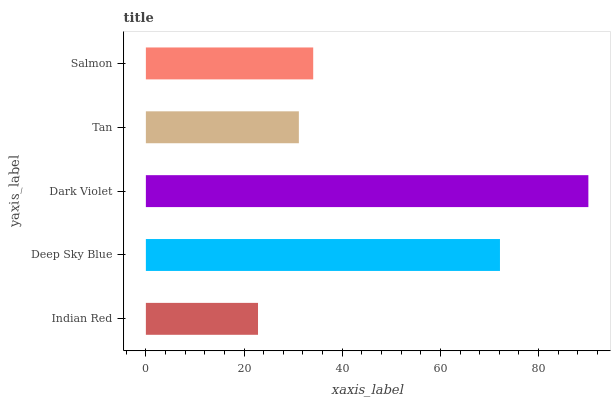Is Indian Red the minimum?
Answer yes or no. Yes. Is Dark Violet the maximum?
Answer yes or no. Yes. Is Deep Sky Blue the minimum?
Answer yes or no. No. Is Deep Sky Blue the maximum?
Answer yes or no. No. Is Deep Sky Blue greater than Indian Red?
Answer yes or no. Yes. Is Indian Red less than Deep Sky Blue?
Answer yes or no. Yes. Is Indian Red greater than Deep Sky Blue?
Answer yes or no. No. Is Deep Sky Blue less than Indian Red?
Answer yes or no. No. Is Salmon the high median?
Answer yes or no. Yes. Is Salmon the low median?
Answer yes or no. Yes. Is Indian Red the high median?
Answer yes or no. No. Is Deep Sky Blue the low median?
Answer yes or no. No. 